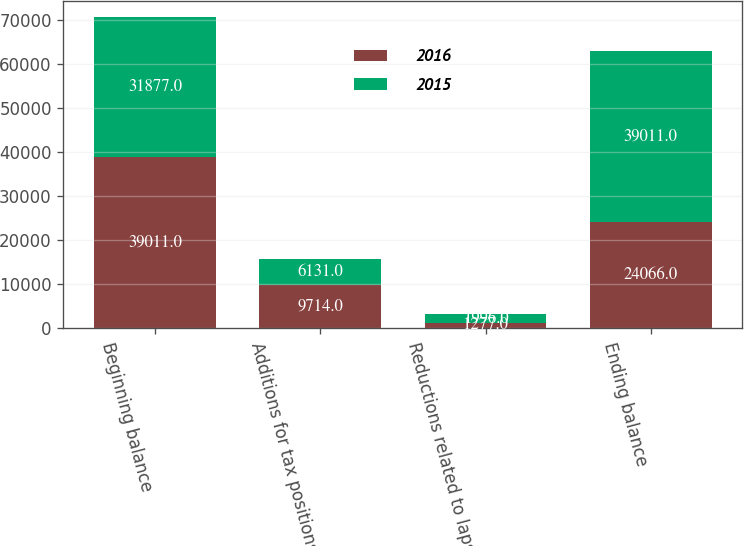<chart> <loc_0><loc_0><loc_500><loc_500><stacked_bar_chart><ecel><fcel>Beginning balance<fcel>Additions for tax positions<fcel>Reductions related to lapse of<fcel>Ending balance<nl><fcel>2016<fcel>39011<fcel>9714<fcel>1277<fcel>24066<nl><fcel>2015<fcel>31877<fcel>6131<fcel>1996<fcel>39011<nl></chart> 